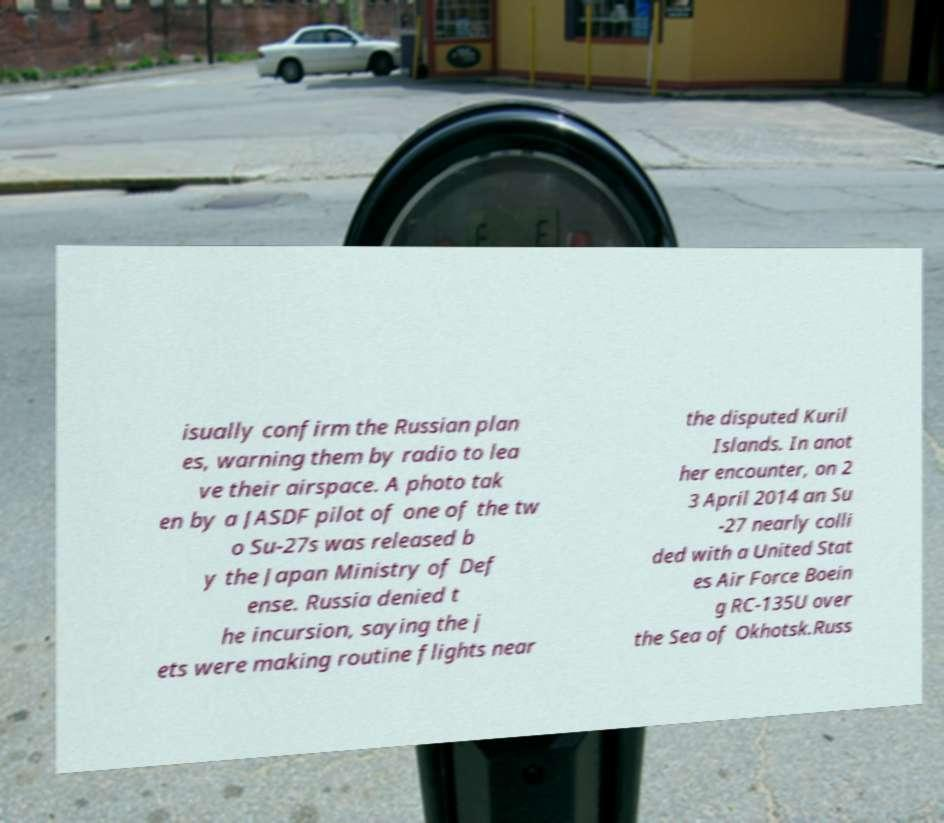For documentation purposes, I need the text within this image transcribed. Could you provide that? isually confirm the Russian plan es, warning them by radio to lea ve their airspace. A photo tak en by a JASDF pilot of one of the tw o Su-27s was released b y the Japan Ministry of Def ense. Russia denied t he incursion, saying the j ets were making routine flights near the disputed Kuril Islands. In anot her encounter, on 2 3 April 2014 an Su -27 nearly colli ded with a United Stat es Air Force Boein g RC-135U over the Sea of Okhotsk.Russ 